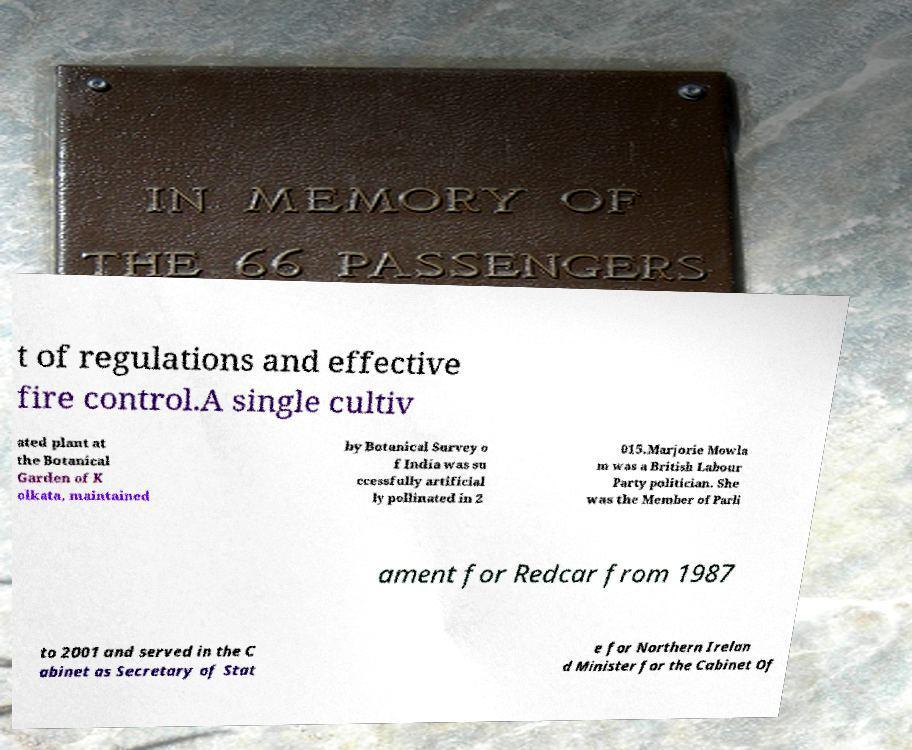Please read and relay the text visible in this image. What does it say? t of regulations and effective fire control.A single cultiv ated plant at the Botanical Garden of K olkata, maintained by Botanical Survey o f India was su ccessfully artificial ly pollinated in 2 015.Marjorie Mowla m was a British Labour Party politician. She was the Member of Parli ament for Redcar from 1987 to 2001 and served in the C abinet as Secretary of Stat e for Northern Irelan d Minister for the Cabinet Of 